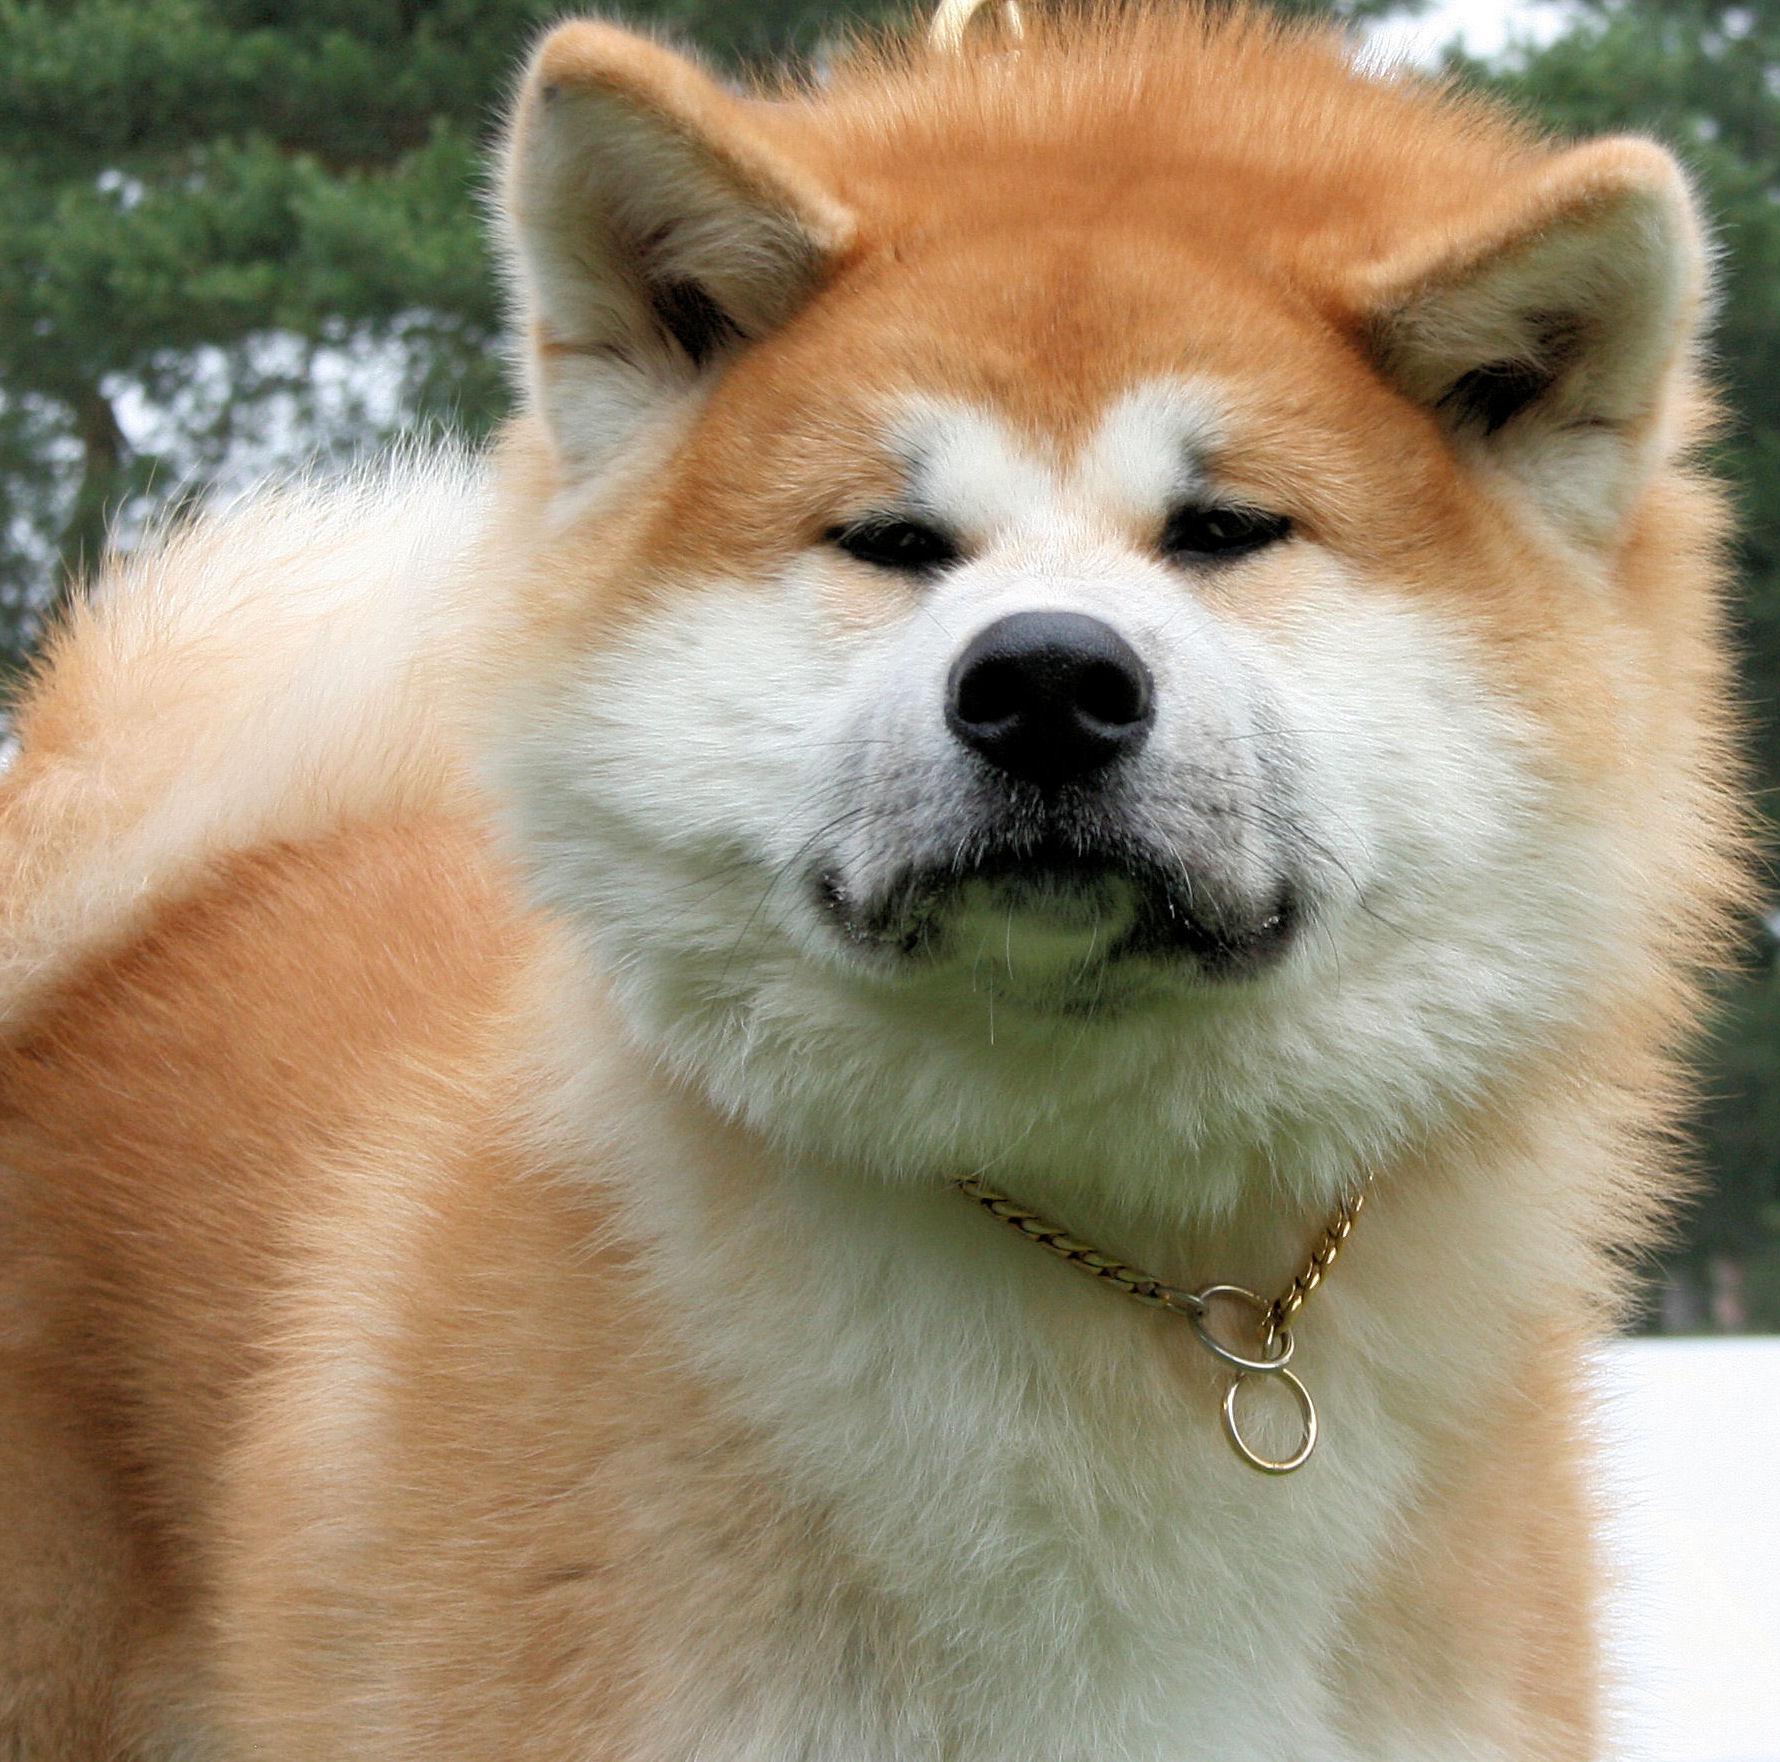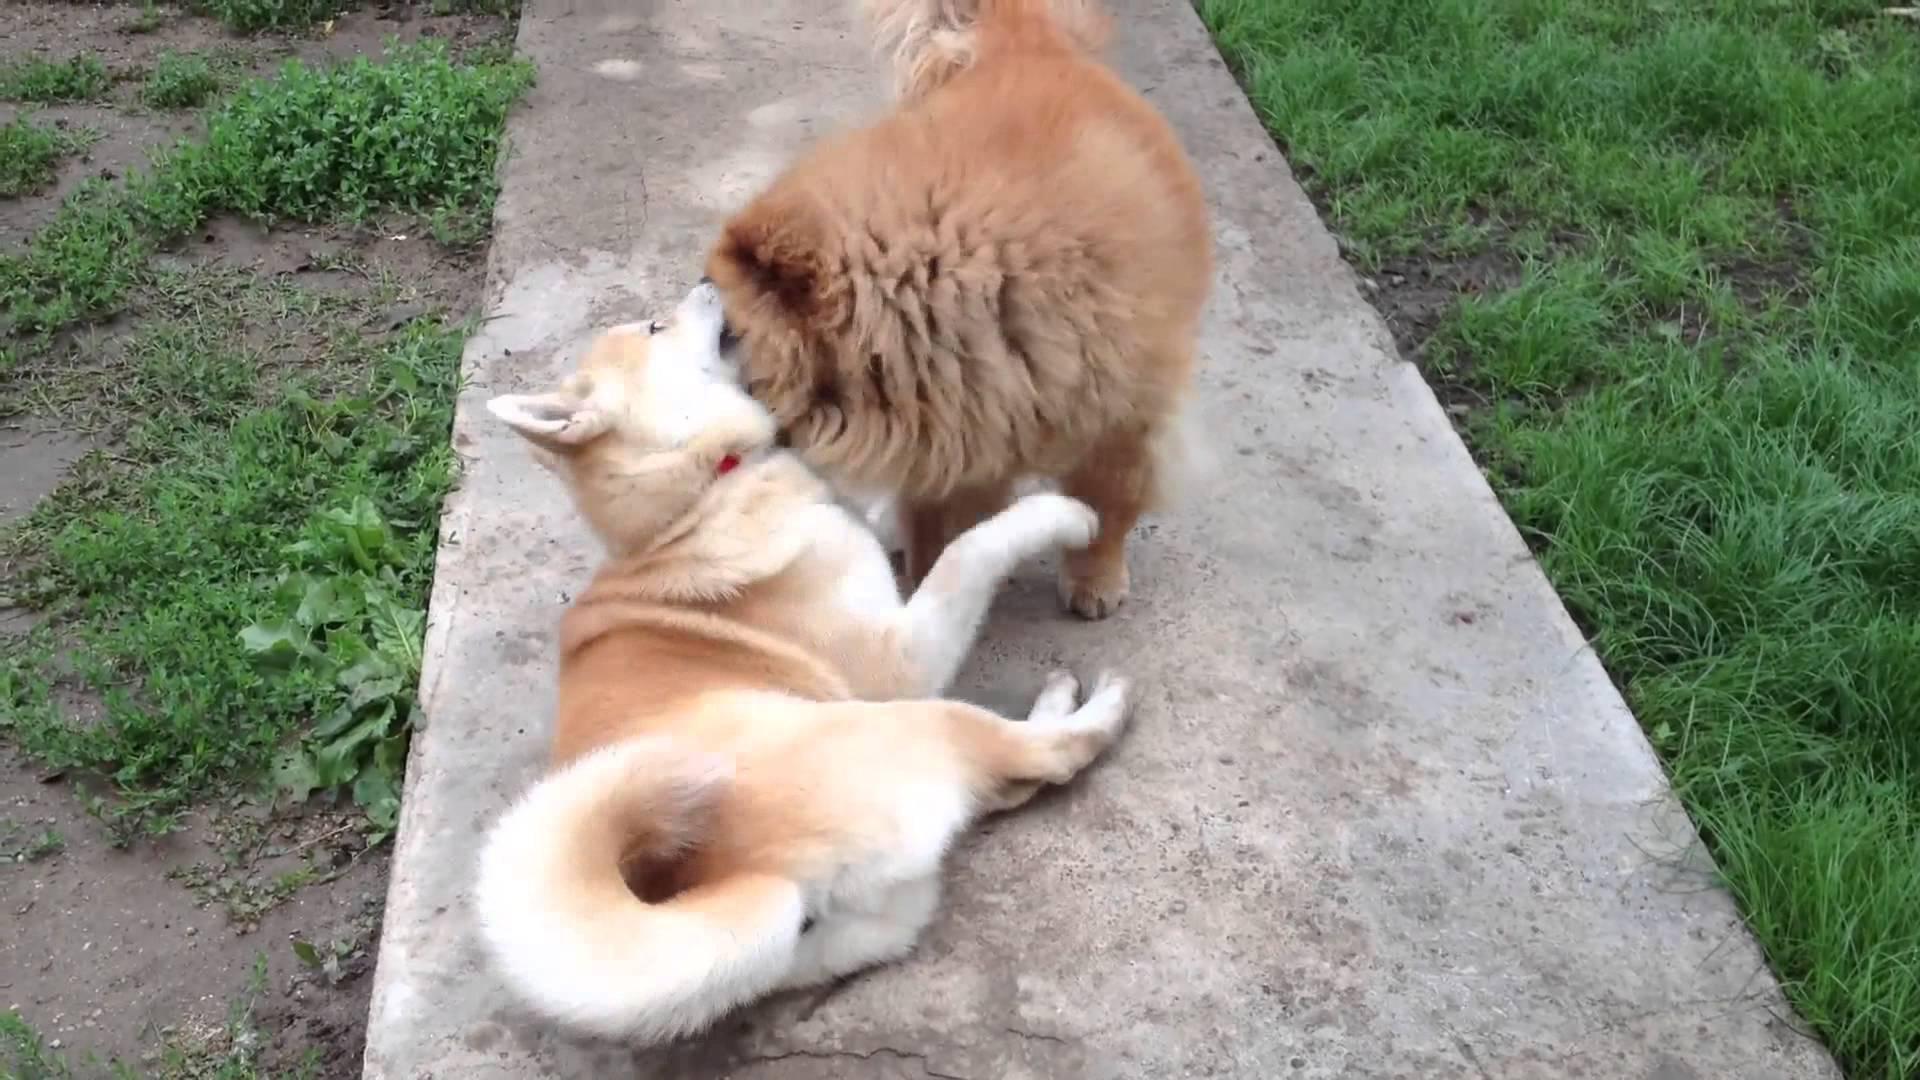The first image is the image on the left, the second image is the image on the right. For the images displayed, is the sentence "Right image features one dog, which is reclining with front paws forward." factually correct? Answer yes or no. No. The first image is the image on the left, the second image is the image on the right. Assess this claim about the two images: "The dog in the image on the left is standing.". Correct or not? Answer yes or no. Yes. 